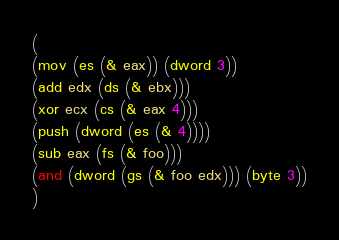<code> <loc_0><loc_0><loc_500><loc_500><_Scheme_>(
(mov (es (& eax)) (dword 3))
(add edx (ds (& ebx)))
(xor ecx (cs (& eax 4)))
(push (dword (es (& 4))))
(sub eax (fs (& foo)))
(and (dword (gs (& foo edx))) (byte 3))
)
</code> 